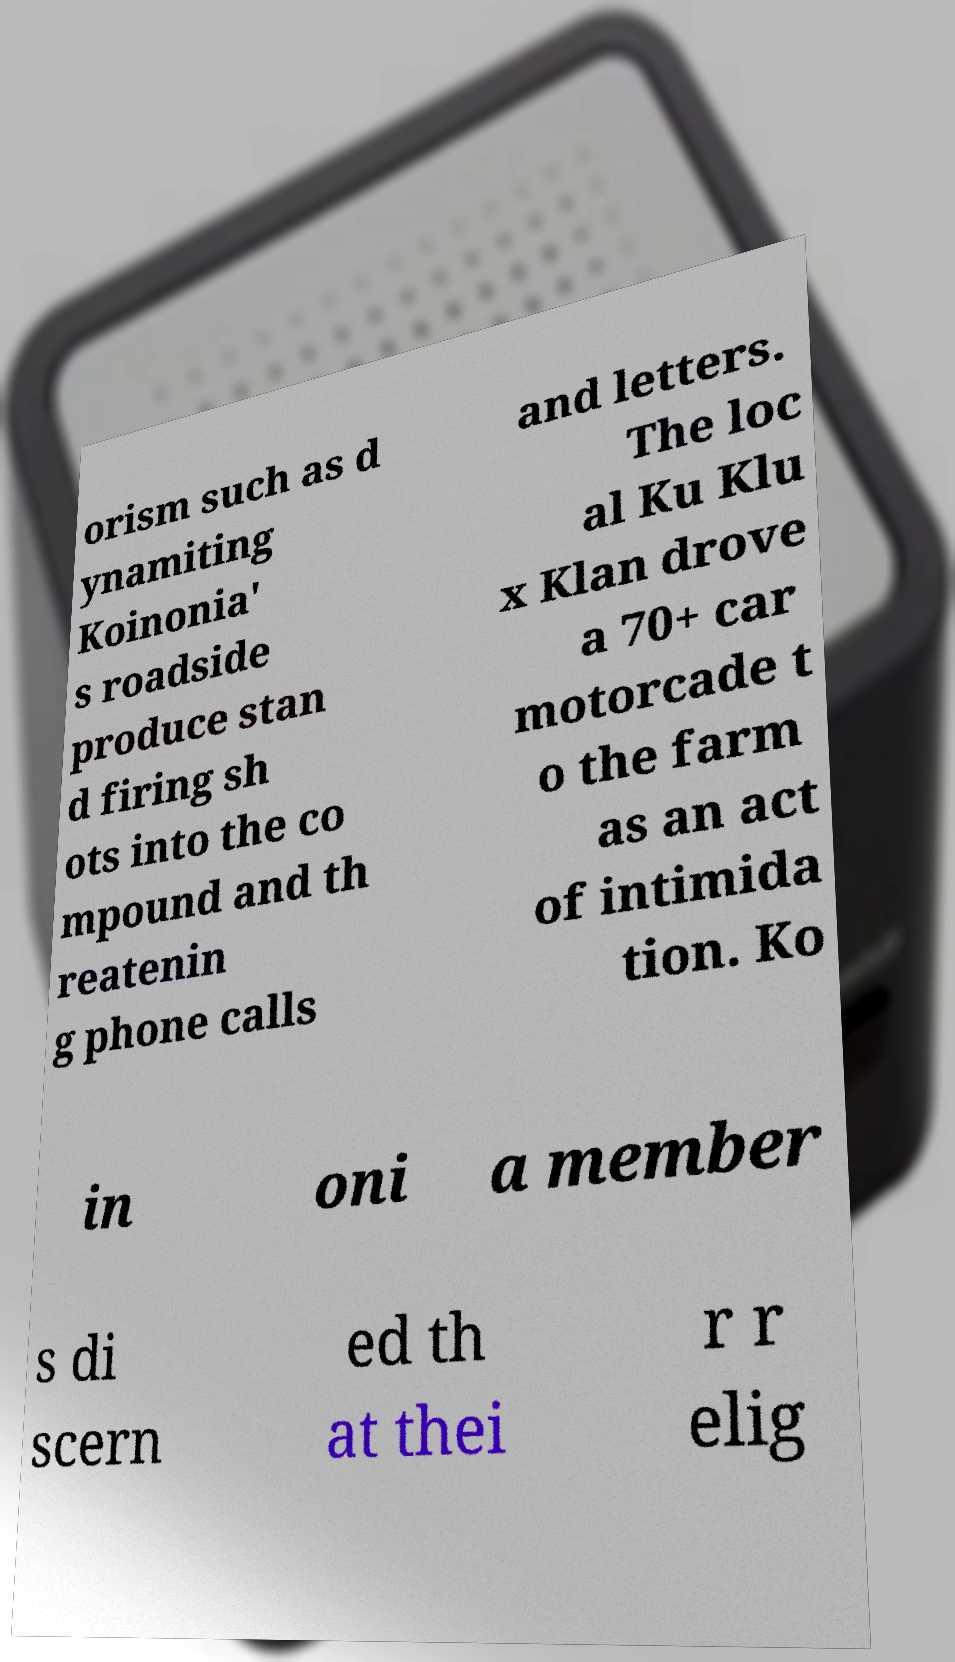What messages or text are displayed in this image? I need them in a readable, typed format. orism such as d ynamiting Koinonia' s roadside produce stan d firing sh ots into the co mpound and th reatenin g phone calls and letters. The loc al Ku Klu x Klan drove a 70+ car motorcade t o the farm as an act of intimida tion. Ko in oni a member s di scern ed th at thei r r elig 